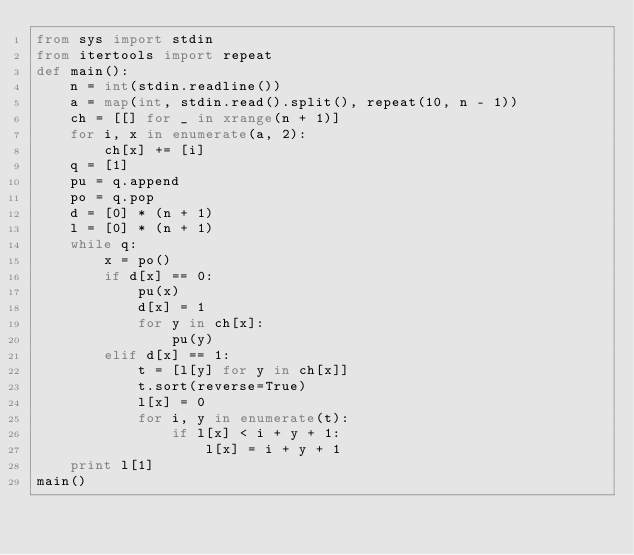Convert code to text. <code><loc_0><loc_0><loc_500><loc_500><_Python_>from sys import stdin
from itertools import repeat
def main():
    n = int(stdin.readline())
    a = map(int, stdin.read().split(), repeat(10, n - 1))
    ch = [[] for _ in xrange(n + 1)]
    for i, x in enumerate(a, 2):
        ch[x] += [i]
    q = [1]
    pu = q.append
    po = q.pop
    d = [0] * (n + 1)
    l = [0] * (n + 1)
    while q:
        x = po()
        if d[x] == 0:
            pu(x)
            d[x] = 1
            for y in ch[x]:
                pu(y)
        elif d[x] == 1:
            t = [l[y] for y in ch[x]]
            t.sort(reverse=True)
            l[x] = 0
            for i, y in enumerate(t):
                if l[x] < i + y + 1:
                    l[x] = i + y + 1
    print l[1]
main()
</code> 